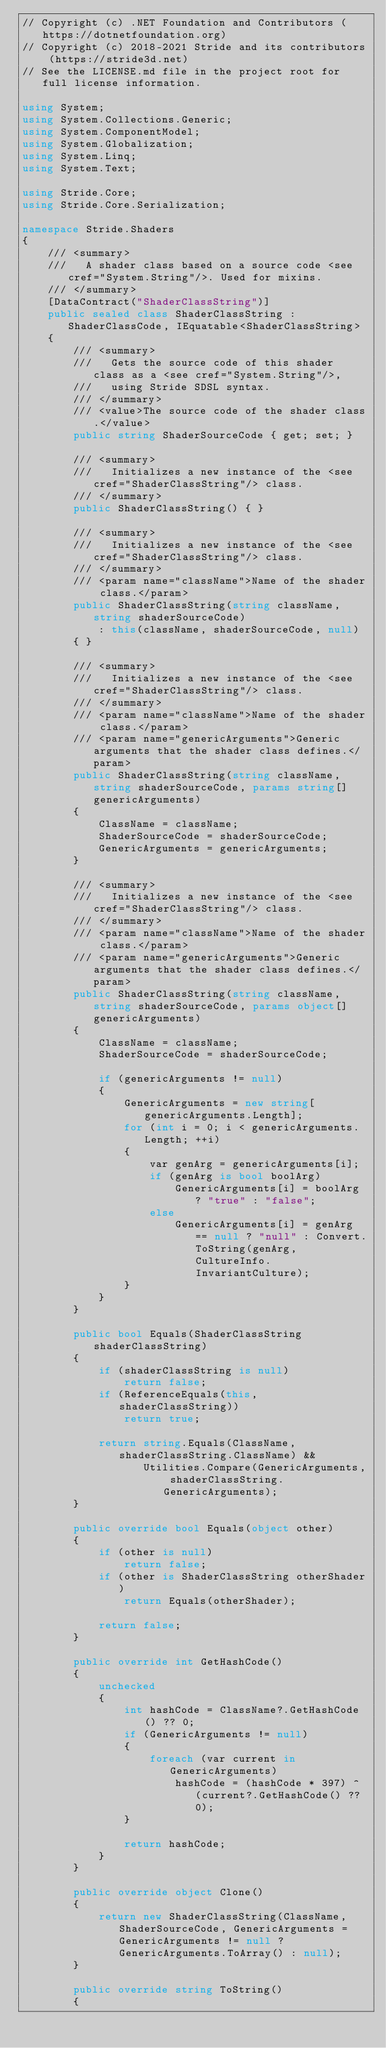<code> <loc_0><loc_0><loc_500><loc_500><_C#_>// Copyright (c) .NET Foundation and Contributors (https://dotnetfoundation.org)
// Copyright (c) 2018-2021 Stride and its contributors (https://stride3d.net)
// See the LICENSE.md file in the project root for full license information.

using System;
using System.Collections.Generic;
using System.ComponentModel;
using System.Globalization;
using System.Linq;
using System.Text;

using Stride.Core;
using Stride.Core.Serialization;

namespace Stride.Shaders
{
    /// <summary>
    ///   A shader class based on a source code <see cref="System.String"/>. Used for mixins.
    /// </summary>
    [DataContract("ShaderClassString")]
    public sealed class ShaderClassString : ShaderClassCode, IEquatable<ShaderClassString>
    {
        /// <summary>
        ///   Gets the source code of this shader class as a <see cref="System.String"/>,
        ///   using Stride SDSL syntax.
        /// </summary>
        /// <value>The source code of the shader class.</value>
        public string ShaderSourceCode { get; set; }

        /// <summary>
        ///   Initializes a new instance of the <see cref="ShaderClassString"/> class.
        /// </summary>
        public ShaderClassString() { }

        /// <summary>
        ///   Initializes a new instance of the <see cref="ShaderClassString"/> class.
        /// </summary>
        /// <param name="className">Name of the shader class.</param>
        public ShaderClassString(string className, string shaderSourceCode)
            : this(className, shaderSourceCode, null)
        { }

        /// <summary>
        ///   Initializes a new instance of the <see cref="ShaderClassString"/> class.
        /// </summary>
        /// <param name="className">Name of the shader class.</param>
        /// <param name="genericArguments">Generic arguments that the shader class defines.</param>
        public ShaderClassString(string className, string shaderSourceCode, params string[] genericArguments)
        {
            ClassName = className;
            ShaderSourceCode = shaderSourceCode;
            GenericArguments = genericArguments;
        }

        /// <summary>
        ///   Initializes a new instance of the <see cref="ShaderClassString"/> class.
        /// </summary>
        /// <param name="className">Name of the shader class.</param>
        /// <param name="genericArguments">Generic arguments that the shader class defines.</param>
        public ShaderClassString(string className, string shaderSourceCode, params object[] genericArguments)
        {
            ClassName = className;
            ShaderSourceCode = shaderSourceCode;

            if (genericArguments != null)
            {
                GenericArguments = new string[genericArguments.Length];
                for (int i = 0; i < genericArguments.Length; ++i)
                {
                    var genArg = genericArguments[i];
                    if (genArg is bool boolArg)
                        GenericArguments[i] = boolArg ? "true" : "false";
                    else
                        GenericArguments[i] = genArg == null ? "null" : Convert.ToString(genArg, CultureInfo.InvariantCulture);
                }
            }
        }

        public bool Equals(ShaderClassString shaderClassString)
        {
            if (shaderClassString is null)
                return false;
            if (ReferenceEquals(this, shaderClassString))
                return true;

            return string.Equals(ClassName, shaderClassString.ClassName) &&
                   Utilities.Compare(GenericArguments, shaderClassString.GenericArguments);
        }

        public override bool Equals(object other)
        {
            if (other is null)
                return false;
            if (other is ShaderClassString otherShader)
                return Equals(otherShader);

            return false;
        }

        public override int GetHashCode()
        {
            unchecked
            {
                int hashCode = ClassName?.GetHashCode() ?? 0;
                if (GenericArguments != null)
                {
                    foreach (var current in GenericArguments)
                        hashCode = (hashCode * 397) ^ (current?.GetHashCode() ?? 0);
                }

                return hashCode;
            }
        }

        public override object Clone()
        {
            return new ShaderClassString(ClassName, ShaderSourceCode, GenericArguments = GenericArguments != null ? GenericArguments.ToArray() : null);
        }

        public override string ToString()
        {</code> 